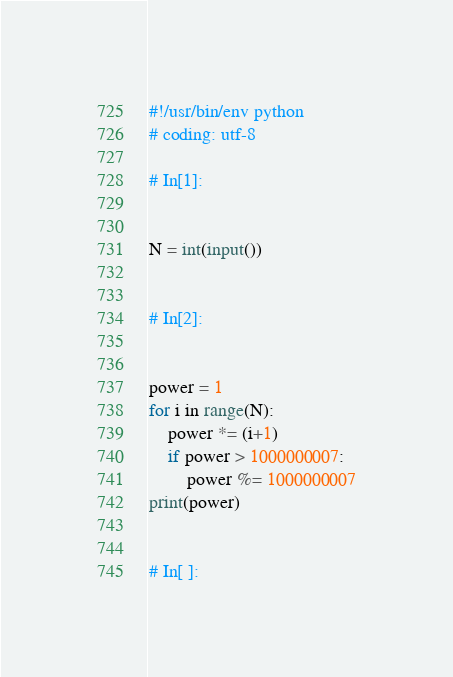Convert code to text. <code><loc_0><loc_0><loc_500><loc_500><_Python_>#!/usr/bin/env python
# coding: utf-8

# In[1]:


N = int(input())


# In[2]:


power = 1
for i in range(N):
    power *= (i+1)
    if power > 1000000007:
        power %= 1000000007
print(power)


# In[ ]:




</code> 